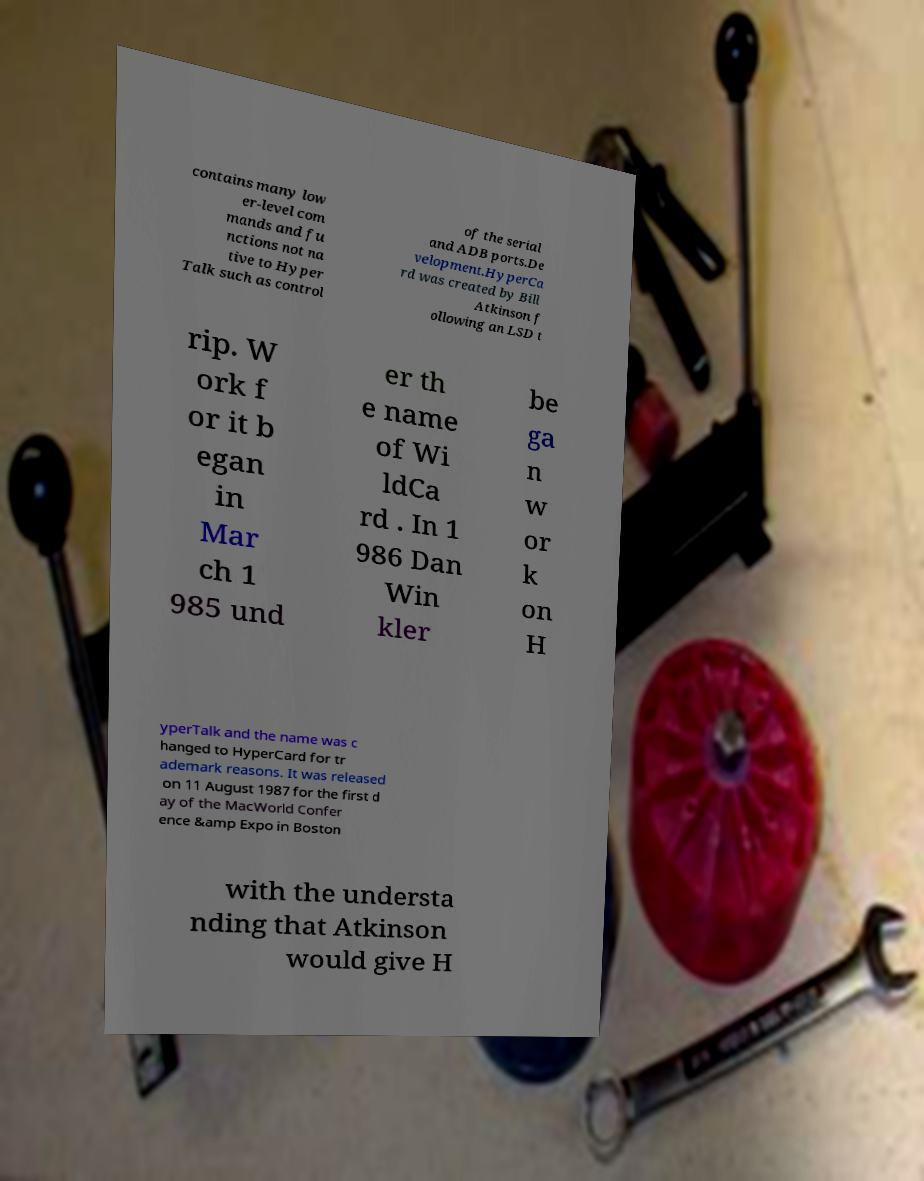Could you extract and type out the text from this image? contains many low er-level com mands and fu nctions not na tive to Hyper Talk such as control of the serial and ADB ports.De velopment.HyperCa rd was created by Bill Atkinson f ollowing an LSD t rip. W ork f or it b egan in Mar ch 1 985 und er th e name of Wi ldCa rd . In 1 986 Dan Win kler be ga n w or k on H yperTalk and the name was c hanged to HyperCard for tr ademark reasons. It was released on 11 August 1987 for the first d ay of the MacWorld Confer ence &amp Expo in Boston with the understa nding that Atkinson would give H 